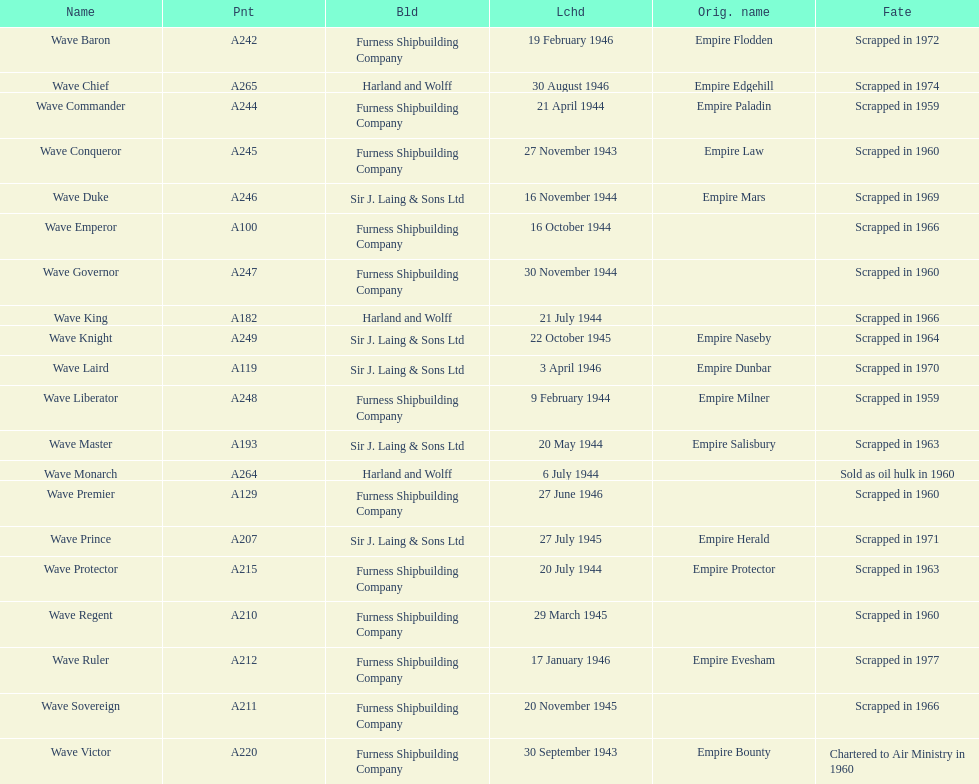Which other ship was launched in the same year as the wave victor? Wave Conqueror. 